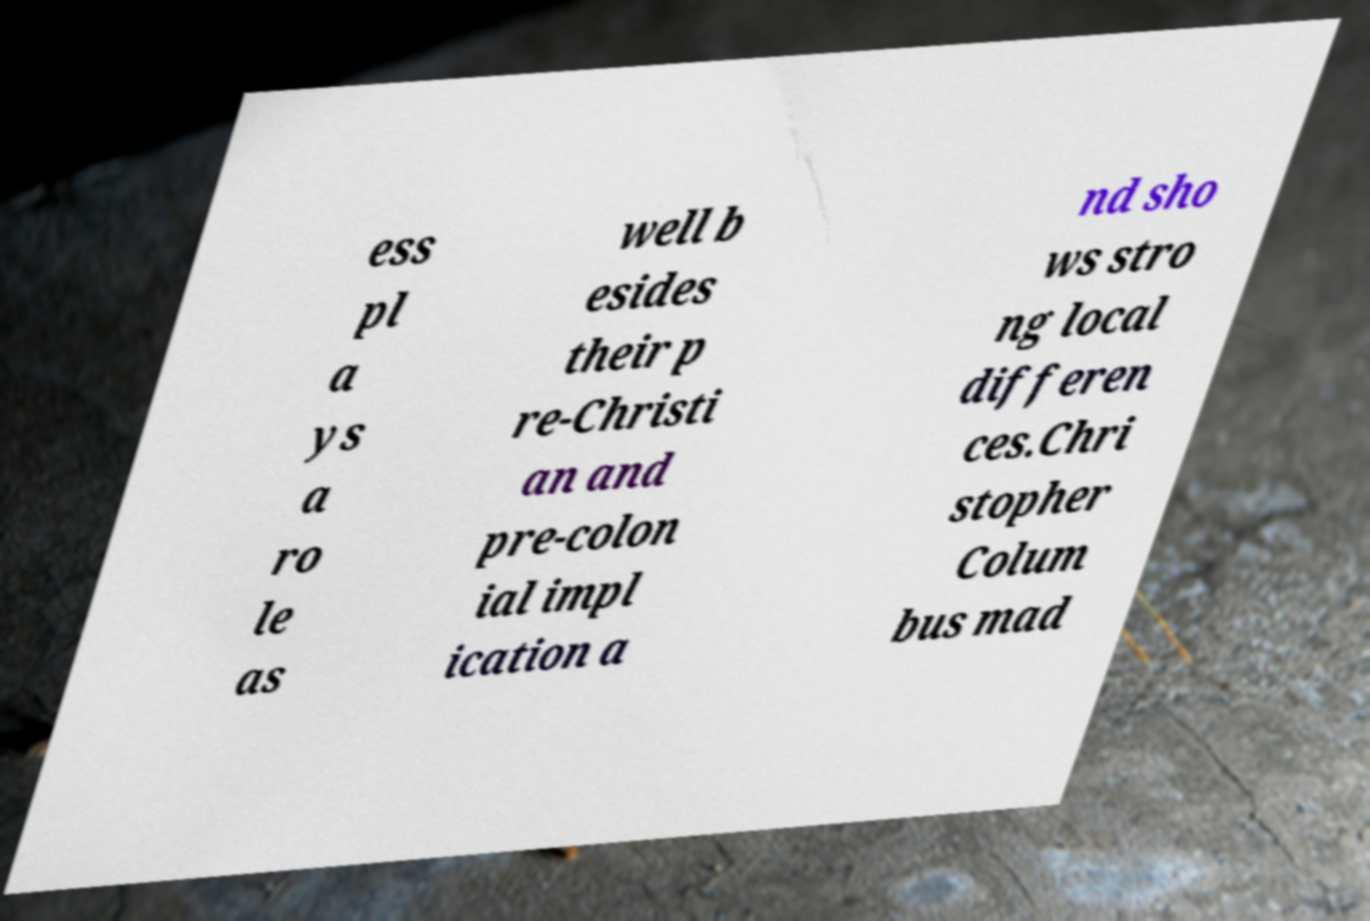Can you read and provide the text displayed in the image?This photo seems to have some interesting text. Can you extract and type it out for me? ess pl a ys a ro le as well b esides their p re-Christi an and pre-colon ial impl ication a nd sho ws stro ng local differen ces.Chri stopher Colum bus mad 